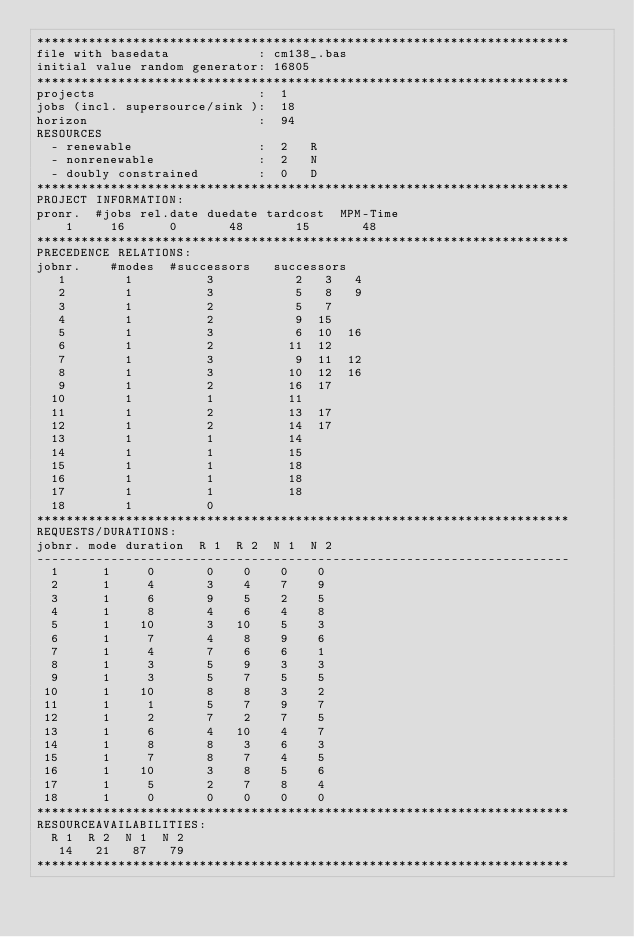<code> <loc_0><loc_0><loc_500><loc_500><_ObjectiveC_>************************************************************************
file with basedata            : cm138_.bas
initial value random generator: 16805
************************************************************************
projects                      :  1
jobs (incl. supersource/sink ):  18
horizon                       :  94
RESOURCES
  - renewable                 :  2   R
  - nonrenewable              :  2   N
  - doubly constrained        :  0   D
************************************************************************
PROJECT INFORMATION:
pronr.  #jobs rel.date duedate tardcost  MPM-Time
    1     16      0       48       15       48
************************************************************************
PRECEDENCE RELATIONS:
jobnr.    #modes  #successors   successors
   1        1          3           2   3   4
   2        1          3           5   8   9
   3        1          2           5   7
   4        1          2           9  15
   5        1          3           6  10  16
   6        1          2          11  12
   7        1          3           9  11  12
   8        1          3          10  12  16
   9        1          2          16  17
  10        1          1          11
  11        1          2          13  17
  12        1          2          14  17
  13        1          1          14
  14        1          1          15
  15        1          1          18
  16        1          1          18
  17        1          1          18
  18        1          0        
************************************************************************
REQUESTS/DURATIONS:
jobnr. mode duration  R 1  R 2  N 1  N 2
------------------------------------------------------------------------
  1      1     0       0    0    0    0
  2      1     4       3    4    7    9
  3      1     6       9    5    2    5
  4      1     8       4    6    4    8
  5      1    10       3   10    5    3
  6      1     7       4    8    9    6
  7      1     4       7    6    6    1
  8      1     3       5    9    3    3
  9      1     3       5    7    5    5
 10      1    10       8    8    3    2
 11      1     1       5    7    9    7
 12      1     2       7    2    7    5
 13      1     6       4   10    4    7
 14      1     8       8    3    6    3
 15      1     7       8    7    4    5
 16      1    10       3    8    5    6
 17      1     5       2    7    8    4
 18      1     0       0    0    0    0
************************************************************************
RESOURCEAVAILABILITIES:
  R 1  R 2  N 1  N 2
   14   21   87   79
************************************************************************
</code> 